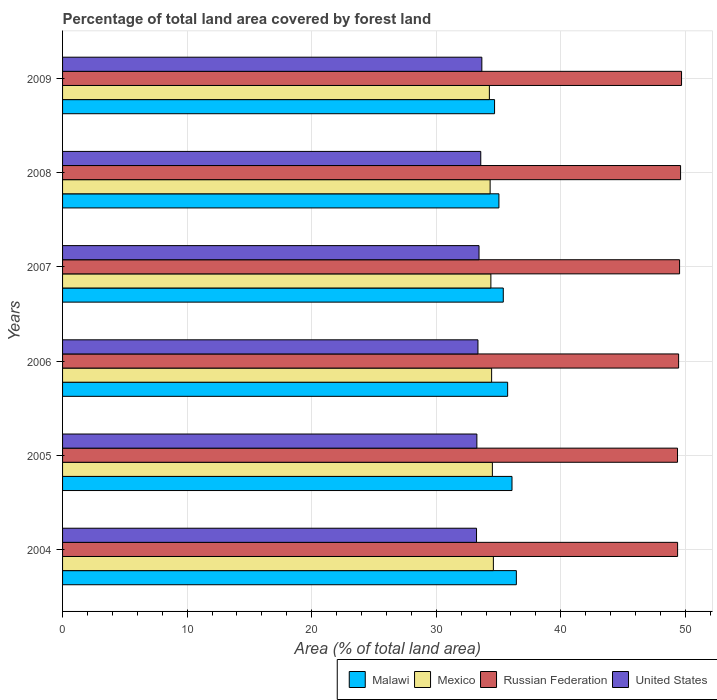How many groups of bars are there?
Your answer should be compact. 6. Are the number of bars per tick equal to the number of legend labels?
Offer a terse response. Yes. Are the number of bars on each tick of the Y-axis equal?
Ensure brevity in your answer.  Yes. How many bars are there on the 3rd tick from the top?
Provide a short and direct response. 4. How many bars are there on the 3rd tick from the bottom?
Your answer should be compact. 4. What is the percentage of forest land in Malawi in 2008?
Provide a short and direct response. 35.03. Across all years, what is the maximum percentage of forest land in Malawi?
Provide a succinct answer. 36.43. Across all years, what is the minimum percentage of forest land in Malawi?
Your answer should be compact. 34.68. In which year was the percentage of forest land in Russian Federation minimum?
Make the answer very short. 2005. What is the total percentage of forest land in United States in the graph?
Your answer should be compact. 200.53. What is the difference between the percentage of forest land in United States in 2005 and that in 2008?
Offer a very short reply. -0.31. What is the difference between the percentage of forest land in United States in 2008 and the percentage of forest land in Mexico in 2007?
Provide a short and direct response. -0.81. What is the average percentage of forest land in United States per year?
Your response must be concise. 33.42. In the year 2009, what is the difference between the percentage of forest land in Russian Federation and percentage of forest land in United States?
Ensure brevity in your answer.  16.03. What is the ratio of the percentage of forest land in Russian Federation in 2004 to that in 2006?
Give a very brief answer. 1. Is the percentage of forest land in Mexico in 2007 less than that in 2009?
Your answer should be compact. No. What is the difference between the highest and the second highest percentage of forest land in Mexico?
Make the answer very short. 0.08. What is the difference between the highest and the lowest percentage of forest land in Mexico?
Your answer should be compact. 0.32. In how many years, is the percentage of forest land in Malawi greater than the average percentage of forest land in Malawi taken over all years?
Ensure brevity in your answer.  3. Is it the case that in every year, the sum of the percentage of forest land in United States and percentage of forest land in Mexico is greater than the sum of percentage of forest land in Russian Federation and percentage of forest land in Malawi?
Provide a short and direct response. Yes. What does the 2nd bar from the top in 2007 represents?
Your answer should be very brief. Russian Federation. What does the 1st bar from the bottom in 2009 represents?
Your answer should be very brief. Malawi. Is it the case that in every year, the sum of the percentage of forest land in United States and percentage of forest land in Mexico is greater than the percentage of forest land in Malawi?
Provide a succinct answer. Yes. How many bars are there?
Offer a terse response. 24. Are all the bars in the graph horizontal?
Give a very brief answer. Yes. How many years are there in the graph?
Give a very brief answer. 6. What is the difference between two consecutive major ticks on the X-axis?
Provide a short and direct response. 10. Are the values on the major ticks of X-axis written in scientific E-notation?
Your answer should be very brief. No. Does the graph contain any zero values?
Give a very brief answer. No. Does the graph contain grids?
Your answer should be very brief. Yes. How are the legend labels stacked?
Make the answer very short. Horizontal. What is the title of the graph?
Offer a very short reply. Percentage of total land area covered by forest land. Does "Canada" appear as one of the legend labels in the graph?
Make the answer very short. No. What is the label or title of the X-axis?
Give a very brief answer. Area (% of total land area). What is the label or title of the Y-axis?
Your response must be concise. Years. What is the Area (% of total land area) in Malawi in 2004?
Provide a short and direct response. 36.43. What is the Area (% of total land area) of Mexico in 2004?
Your answer should be very brief. 34.59. What is the Area (% of total land area) of Russian Federation in 2004?
Offer a terse response. 49.38. What is the Area (% of total land area) in United States in 2004?
Your answer should be compact. 33.24. What is the Area (% of total land area) in Malawi in 2005?
Ensure brevity in your answer.  36.08. What is the Area (% of total land area) in Mexico in 2005?
Your answer should be very brief. 34.51. What is the Area (% of total land area) of Russian Federation in 2005?
Your answer should be very brief. 49.37. What is the Area (% of total land area) of United States in 2005?
Keep it short and to the point. 33.26. What is the Area (% of total land area) of Malawi in 2006?
Keep it short and to the point. 35.73. What is the Area (% of total land area) in Mexico in 2006?
Provide a succinct answer. 34.45. What is the Area (% of total land area) in Russian Federation in 2006?
Ensure brevity in your answer.  49.46. What is the Area (% of total land area) in United States in 2006?
Offer a very short reply. 33.35. What is the Area (% of total land area) in Malawi in 2007?
Your answer should be very brief. 35.38. What is the Area (% of total land area) in Mexico in 2007?
Ensure brevity in your answer.  34.39. What is the Area (% of total land area) in Russian Federation in 2007?
Keep it short and to the point. 49.54. What is the Area (% of total land area) in United States in 2007?
Your answer should be compact. 33.44. What is the Area (% of total land area) of Malawi in 2008?
Provide a short and direct response. 35.03. What is the Area (% of total land area) of Mexico in 2008?
Give a very brief answer. 34.33. What is the Area (% of total land area) of Russian Federation in 2008?
Your answer should be compact. 49.62. What is the Area (% of total land area) in United States in 2008?
Your response must be concise. 33.58. What is the Area (% of total land area) in Malawi in 2009?
Provide a succinct answer. 34.68. What is the Area (% of total land area) of Mexico in 2009?
Offer a very short reply. 34.27. What is the Area (% of total land area) of Russian Federation in 2009?
Offer a very short reply. 49.7. What is the Area (% of total land area) in United States in 2009?
Your answer should be compact. 33.66. Across all years, what is the maximum Area (% of total land area) in Malawi?
Your answer should be compact. 36.43. Across all years, what is the maximum Area (% of total land area) in Mexico?
Give a very brief answer. 34.59. Across all years, what is the maximum Area (% of total land area) in Russian Federation?
Offer a terse response. 49.7. Across all years, what is the maximum Area (% of total land area) of United States?
Provide a succinct answer. 33.66. Across all years, what is the minimum Area (% of total land area) in Malawi?
Make the answer very short. 34.68. Across all years, what is the minimum Area (% of total land area) of Mexico?
Your answer should be compact. 34.27. Across all years, what is the minimum Area (% of total land area) of Russian Federation?
Provide a succinct answer. 49.37. Across all years, what is the minimum Area (% of total land area) in United States?
Give a very brief answer. 33.24. What is the total Area (% of total land area) in Malawi in the graph?
Offer a terse response. 213.35. What is the total Area (% of total land area) in Mexico in the graph?
Ensure brevity in your answer.  206.53. What is the total Area (% of total land area) in Russian Federation in the graph?
Your response must be concise. 297.07. What is the total Area (% of total land area) of United States in the graph?
Give a very brief answer. 200.53. What is the difference between the Area (% of total land area) of Malawi in 2004 and that in 2005?
Your answer should be very brief. 0.35. What is the difference between the Area (% of total land area) of Mexico in 2004 and that in 2005?
Ensure brevity in your answer.  0.08. What is the difference between the Area (% of total land area) of Russian Federation in 2004 and that in 2005?
Give a very brief answer. 0.01. What is the difference between the Area (% of total land area) in United States in 2004 and that in 2005?
Make the answer very short. -0.03. What is the difference between the Area (% of total land area) of Mexico in 2004 and that in 2006?
Keep it short and to the point. 0.14. What is the difference between the Area (% of total land area) of Russian Federation in 2004 and that in 2006?
Your answer should be very brief. -0.08. What is the difference between the Area (% of total land area) in United States in 2004 and that in 2006?
Your response must be concise. -0.11. What is the difference between the Area (% of total land area) in Malawi in 2004 and that in 2007?
Provide a short and direct response. 1.05. What is the difference between the Area (% of total land area) of Mexico in 2004 and that in 2007?
Offer a terse response. 0.2. What is the difference between the Area (% of total land area) in Russian Federation in 2004 and that in 2007?
Ensure brevity in your answer.  -0.16. What is the difference between the Area (% of total land area) in United States in 2004 and that in 2007?
Your answer should be compact. -0.2. What is the difference between the Area (% of total land area) in Malawi in 2004 and that in 2008?
Your answer should be compact. 1.4. What is the difference between the Area (% of total land area) of Mexico in 2004 and that in 2008?
Provide a short and direct response. 0.26. What is the difference between the Area (% of total land area) in Russian Federation in 2004 and that in 2008?
Make the answer very short. -0.24. What is the difference between the Area (% of total land area) in United States in 2004 and that in 2008?
Keep it short and to the point. -0.34. What is the difference between the Area (% of total land area) in Malawi in 2004 and that in 2009?
Provide a short and direct response. 1.75. What is the difference between the Area (% of total land area) in Mexico in 2004 and that in 2009?
Your response must be concise. 0.32. What is the difference between the Area (% of total land area) of Russian Federation in 2004 and that in 2009?
Your response must be concise. -0.32. What is the difference between the Area (% of total land area) in United States in 2004 and that in 2009?
Offer a terse response. -0.43. What is the difference between the Area (% of total land area) in Mexico in 2005 and that in 2006?
Offer a terse response. 0.06. What is the difference between the Area (% of total land area) in Russian Federation in 2005 and that in 2006?
Offer a terse response. -0.09. What is the difference between the Area (% of total land area) of United States in 2005 and that in 2006?
Offer a terse response. -0.09. What is the difference between the Area (% of total land area) in Mexico in 2005 and that in 2007?
Keep it short and to the point. 0.12. What is the difference between the Area (% of total land area) in Russian Federation in 2005 and that in 2007?
Make the answer very short. -0.17. What is the difference between the Area (% of total land area) of United States in 2005 and that in 2007?
Your answer should be very brief. -0.17. What is the difference between the Area (% of total land area) in Malawi in 2005 and that in 2008?
Your answer should be compact. 1.05. What is the difference between the Area (% of total land area) in Mexico in 2005 and that in 2008?
Provide a succinct answer. 0.18. What is the difference between the Area (% of total land area) of Russian Federation in 2005 and that in 2008?
Offer a terse response. -0.25. What is the difference between the Area (% of total land area) of United States in 2005 and that in 2008?
Your response must be concise. -0.31. What is the difference between the Area (% of total land area) in Malawi in 2005 and that in 2009?
Provide a short and direct response. 1.4. What is the difference between the Area (% of total land area) in Mexico in 2005 and that in 2009?
Provide a succinct answer. 0.24. What is the difference between the Area (% of total land area) of Russian Federation in 2005 and that in 2009?
Keep it short and to the point. -0.32. What is the difference between the Area (% of total land area) of United States in 2005 and that in 2009?
Your answer should be compact. -0.4. What is the difference between the Area (% of total land area) of Malawi in 2006 and that in 2007?
Offer a very short reply. 0.35. What is the difference between the Area (% of total land area) in Mexico in 2006 and that in 2007?
Give a very brief answer. 0.06. What is the difference between the Area (% of total land area) of Russian Federation in 2006 and that in 2007?
Provide a short and direct response. -0.08. What is the difference between the Area (% of total land area) of United States in 2006 and that in 2007?
Ensure brevity in your answer.  -0.09. What is the difference between the Area (% of total land area) in Mexico in 2006 and that in 2008?
Provide a succinct answer. 0.12. What is the difference between the Area (% of total land area) in Russian Federation in 2006 and that in 2008?
Your answer should be very brief. -0.16. What is the difference between the Area (% of total land area) in United States in 2006 and that in 2008?
Your answer should be very brief. -0.23. What is the difference between the Area (% of total land area) in Malawi in 2006 and that in 2009?
Make the answer very short. 1.05. What is the difference between the Area (% of total land area) in Mexico in 2006 and that in 2009?
Ensure brevity in your answer.  0.18. What is the difference between the Area (% of total land area) of Russian Federation in 2006 and that in 2009?
Make the answer very short. -0.24. What is the difference between the Area (% of total land area) of United States in 2006 and that in 2009?
Your response must be concise. -0.31. What is the difference between the Area (% of total land area) of Malawi in 2007 and that in 2008?
Provide a succinct answer. 0.35. What is the difference between the Area (% of total land area) of Mexico in 2007 and that in 2008?
Keep it short and to the point. 0.06. What is the difference between the Area (% of total land area) in Russian Federation in 2007 and that in 2008?
Offer a terse response. -0.08. What is the difference between the Area (% of total land area) in United States in 2007 and that in 2008?
Offer a terse response. -0.14. What is the difference between the Area (% of total land area) of Mexico in 2007 and that in 2009?
Your answer should be very brief. 0.12. What is the difference between the Area (% of total land area) of Russian Federation in 2007 and that in 2009?
Your response must be concise. -0.16. What is the difference between the Area (% of total land area) in United States in 2007 and that in 2009?
Your response must be concise. -0.23. What is the difference between the Area (% of total land area) of Malawi in 2008 and that in 2009?
Your answer should be compact. 0.35. What is the difference between the Area (% of total land area) in Mexico in 2008 and that in 2009?
Your response must be concise. 0.06. What is the difference between the Area (% of total land area) of Russian Federation in 2008 and that in 2009?
Your answer should be very brief. -0.08. What is the difference between the Area (% of total land area) in United States in 2008 and that in 2009?
Offer a terse response. -0.09. What is the difference between the Area (% of total land area) of Malawi in 2004 and the Area (% of total land area) of Mexico in 2005?
Give a very brief answer. 1.93. What is the difference between the Area (% of total land area) of Malawi in 2004 and the Area (% of total land area) of Russian Federation in 2005?
Provide a short and direct response. -12.94. What is the difference between the Area (% of total land area) in Malawi in 2004 and the Area (% of total land area) in United States in 2005?
Ensure brevity in your answer.  3.17. What is the difference between the Area (% of total land area) of Mexico in 2004 and the Area (% of total land area) of Russian Federation in 2005?
Keep it short and to the point. -14.78. What is the difference between the Area (% of total land area) of Mexico in 2004 and the Area (% of total land area) of United States in 2005?
Your answer should be very brief. 1.32. What is the difference between the Area (% of total land area) in Russian Federation in 2004 and the Area (% of total land area) in United States in 2005?
Your answer should be very brief. 16.12. What is the difference between the Area (% of total land area) in Malawi in 2004 and the Area (% of total land area) in Mexico in 2006?
Provide a succinct answer. 1.99. What is the difference between the Area (% of total land area) in Malawi in 2004 and the Area (% of total land area) in Russian Federation in 2006?
Keep it short and to the point. -13.03. What is the difference between the Area (% of total land area) in Malawi in 2004 and the Area (% of total land area) in United States in 2006?
Keep it short and to the point. 3.08. What is the difference between the Area (% of total land area) of Mexico in 2004 and the Area (% of total land area) of Russian Federation in 2006?
Ensure brevity in your answer.  -14.87. What is the difference between the Area (% of total land area) in Mexico in 2004 and the Area (% of total land area) in United States in 2006?
Provide a short and direct response. 1.24. What is the difference between the Area (% of total land area) of Russian Federation in 2004 and the Area (% of total land area) of United States in 2006?
Offer a terse response. 16.03. What is the difference between the Area (% of total land area) in Malawi in 2004 and the Area (% of total land area) in Mexico in 2007?
Give a very brief answer. 2.05. What is the difference between the Area (% of total land area) of Malawi in 2004 and the Area (% of total land area) of Russian Federation in 2007?
Your answer should be very brief. -13.1. What is the difference between the Area (% of total land area) in Malawi in 2004 and the Area (% of total land area) in United States in 2007?
Provide a short and direct response. 3. What is the difference between the Area (% of total land area) in Mexico in 2004 and the Area (% of total land area) in Russian Federation in 2007?
Provide a succinct answer. -14.95. What is the difference between the Area (% of total land area) of Mexico in 2004 and the Area (% of total land area) of United States in 2007?
Offer a terse response. 1.15. What is the difference between the Area (% of total land area) in Russian Federation in 2004 and the Area (% of total land area) in United States in 2007?
Provide a short and direct response. 15.94. What is the difference between the Area (% of total land area) in Malawi in 2004 and the Area (% of total land area) in Mexico in 2008?
Make the answer very short. 2.11. What is the difference between the Area (% of total land area) in Malawi in 2004 and the Area (% of total land area) in Russian Federation in 2008?
Provide a succinct answer. -13.18. What is the difference between the Area (% of total land area) in Malawi in 2004 and the Area (% of total land area) in United States in 2008?
Provide a short and direct response. 2.86. What is the difference between the Area (% of total land area) in Mexico in 2004 and the Area (% of total land area) in Russian Federation in 2008?
Your response must be concise. -15.03. What is the difference between the Area (% of total land area) in Mexico in 2004 and the Area (% of total land area) in United States in 2008?
Your answer should be very brief. 1.01. What is the difference between the Area (% of total land area) in Russian Federation in 2004 and the Area (% of total land area) in United States in 2008?
Ensure brevity in your answer.  15.8. What is the difference between the Area (% of total land area) of Malawi in 2004 and the Area (% of total land area) of Mexico in 2009?
Your response must be concise. 2.17. What is the difference between the Area (% of total land area) in Malawi in 2004 and the Area (% of total land area) in Russian Federation in 2009?
Make the answer very short. -13.26. What is the difference between the Area (% of total land area) of Malawi in 2004 and the Area (% of total land area) of United States in 2009?
Your answer should be compact. 2.77. What is the difference between the Area (% of total land area) of Mexico in 2004 and the Area (% of total land area) of Russian Federation in 2009?
Your answer should be very brief. -15.11. What is the difference between the Area (% of total land area) of Mexico in 2004 and the Area (% of total land area) of United States in 2009?
Your response must be concise. 0.93. What is the difference between the Area (% of total land area) of Russian Federation in 2004 and the Area (% of total land area) of United States in 2009?
Your response must be concise. 15.72. What is the difference between the Area (% of total land area) in Malawi in 2005 and the Area (% of total land area) in Mexico in 2006?
Your answer should be compact. 1.64. What is the difference between the Area (% of total land area) in Malawi in 2005 and the Area (% of total land area) in Russian Federation in 2006?
Offer a terse response. -13.38. What is the difference between the Area (% of total land area) in Malawi in 2005 and the Area (% of total land area) in United States in 2006?
Make the answer very short. 2.73. What is the difference between the Area (% of total land area) of Mexico in 2005 and the Area (% of total land area) of Russian Federation in 2006?
Offer a terse response. -14.95. What is the difference between the Area (% of total land area) in Mexico in 2005 and the Area (% of total land area) in United States in 2006?
Your response must be concise. 1.16. What is the difference between the Area (% of total land area) in Russian Federation in 2005 and the Area (% of total land area) in United States in 2006?
Give a very brief answer. 16.02. What is the difference between the Area (% of total land area) in Malawi in 2005 and the Area (% of total land area) in Mexico in 2007?
Your answer should be compact. 1.7. What is the difference between the Area (% of total land area) of Malawi in 2005 and the Area (% of total land area) of Russian Federation in 2007?
Provide a short and direct response. -13.45. What is the difference between the Area (% of total land area) of Malawi in 2005 and the Area (% of total land area) of United States in 2007?
Give a very brief answer. 2.65. What is the difference between the Area (% of total land area) in Mexico in 2005 and the Area (% of total land area) in Russian Federation in 2007?
Provide a short and direct response. -15.03. What is the difference between the Area (% of total land area) of Mexico in 2005 and the Area (% of total land area) of United States in 2007?
Ensure brevity in your answer.  1.07. What is the difference between the Area (% of total land area) in Russian Federation in 2005 and the Area (% of total land area) in United States in 2007?
Your answer should be very brief. 15.94. What is the difference between the Area (% of total land area) of Malawi in 2005 and the Area (% of total land area) of Mexico in 2008?
Ensure brevity in your answer.  1.76. What is the difference between the Area (% of total land area) in Malawi in 2005 and the Area (% of total land area) in Russian Federation in 2008?
Ensure brevity in your answer.  -13.53. What is the difference between the Area (% of total land area) of Malawi in 2005 and the Area (% of total land area) of United States in 2008?
Offer a terse response. 2.51. What is the difference between the Area (% of total land area) of Mexico in 2005 and the Area (% of total land area) of Russian Federation in 2008?
Ensure brevity in your answer.  -15.11. What is the difference between the Area (% of total land area) in Mexico in 2005 and the Area (% of total land area) in United States in 2008?
Offer a terse response. 0.93. What is the difference between the Area (% of total land area) of Russian Federation in 2005 and the Area (% of total land area) of United States in 2008?
Keep it short and to the point. 15.8. What is the difference between the Area (% of total land area) of Malawi in 2005 and the Area (% of total land area) of Mexico in 2009?
Your answer should be very brief. 1.82. What is the difference between the Area (% of total land area) in Malawi in 2005 and the Area (% of total land area) in Russian Federation in 2009?
Make the answer very short. -13.61. What is the difference between the Area (% of total land area) in Malawi in 2005 and the Area (% of total land area) in United States in 2009?
Give a very brief answer. 2.42. What is the difference between the Area (% of total land area) in Mexico in 2005 and the Area (% of total land area) in Russian Federation in 2009?
Ensure brevity in your answer.  -15.19. What is the difference between the Area (% of total land area) of Mexico in 2005 and the Area (% of total land area) of United States in 2009?
Offer a terse response. 0.85. What is the difference between the Area (% of total land area) of Russian Federation in 2005 and the Area (% of total land area) of United States in 2009?
Provide a succinct answer. 15.71. What is the difference between the Area (% of total land area) of Malawi in 2006 and the Area (% of total land area) of Mexico in 2007?
Your answer should be very brief. 1.35. What is the difference between the Area (% of total land area) of Malawi in 2006 and the Area (% of total land area) of Russian Federation in 2007?
Ensure brevity in your answer.  -13.8. What is the difference between the Area (% of total land area) in Malawi in 2006 and the Area (% of total land area) in United States in 2007?
Make the answer very short. 2.3. What is the difference between the Area (% of total land area) in Mexico in 2006 and the Area (% of total land area) in Russian Federation in 2007?
Give a very brief answer. -15.09. What is the difference between the Area (% of total land area) in Russian Federation in 2006 and the Area (% of total land area) in United States in 2007?
Offer a very short reply. 16.02. What is the difference between the Area (% of total land area) of Malawi in 2006 and the Area (% of total land area) of Mexico in 2008?
Your response must be concise. 1.41. What is the difference between the Area (% of total land area) in Malawi in 2006 and the Area (% of total land area) in Russian Federation in 2008?
Your answer should be very brief. -13.88. What is the difference between the Area (% of total land area) of Malawi in 2006 and the Area (% of total land area) of United States in 2008?
Give a very brief answer. 2.16. What is the difference between the Area (% of total land area) in Mexico in 2006 and the Area (% of total land area) in Russian Federation in 2008?
Provide a short and direct response. -15.17. What is the difference between the Area (% of total land area) of Mexico in 2006 and the Area (% of total land area) of United States in 2008?
Keep it short and to the point. 0.87. What is the difference between the Area (% of total land area) in Russian Federation in 2006 and the Area (% of total land area) in United States in 2008?
Your answer should be very brief. 15.88. What is the difference between the Area (% of total land area) of Malawi in 2006 and the Area (% of total land area) of Mexico in 2009?
Your response must be concise. 1.47. What is the difference between the Area (% of total land area) of Malawi in 2006 and the Area (% of total land area) of Russian Federation in 2009?
Offer a terse response. -13.96. What is the difference between the Area (% of total land area) of Malawi in 2006 and the Area (% of total land area) of United States in 2009?
Provide a succinct answer. 2.07. What is the difference between the Area (% of total land area) in Mexico in 2006 and the Area (% of total land area) in Russian Federation in 2009?
Your answer should be very brief. -15.25. What is the difference between the Area (% of total land area) in Mexico in 2006 and the Area (% of total land area) in United States in 2009?
Provide a succinct answer. 0.79. What is the difference between the Area (% of total land area) in Russian Federation in 2006 and the Area (% of total land area) in United States in 2009?
Keep it short and to the point. 15.8. What is the difference between the Area (% of total land area) in Malawi in 2007 and the Area (% of total land area) in Mexico in 2008?
Keep it short and to the point. 1.06. What is the difference between the Area (% of total land area) of Malawi in 2007 and the Area (% of total land area) of Russian Federation in 2008?
Provide a short and direct response. -14.23. What is the difference between the Area (% of total land area) of Malawi in 2007 and the Area (% of total land area) of United States in 2008?
Offer a very short reply. 1.81. What is the difference between the Area (% of total land area) in Mexico in 2007 and the Area (% of total land area) in Russian Federation in 2008?
Your answer should be very brief. -15.23. What is the difference between the Area (% of total land area) of Mexico in 2007 and the Area (% of total land area) of United States in 2008?
Make the answer very short. 0.81. What is the difference between the Area (% of total land area) of Russian Federation in 2007 and the Area (% of total land area) of United States in 2008?
Give a very brief answer. 15.96. What is the difference between the Area (% of total land area) in Malawi in 2007 and the Area (% of total land area) in Mexico in 2009?
Your answer should be very brief. 1.12. What is the difference between the Area (% of total land area) of Malawi in 2007 and the Area (% of total land area) of Russian Federation in 2009?
Ensure brevity in your answer.  -14.31. What is the difference between the Area (% of total land area) of Malawi in 2007 and the Area (% of total land area) of United States in 2009?
Your response must be concise. 1.72. What is the difference between the Area (% of total land area) in Mexico in 2007 and the Area (% of total land area) in Russian Federation in 2009?
Offer a very short reply. -15.31. What is the difference between the Area (% of total land area) in Mexico in 2007 and the Area (% of total land area) in United States in 2009?
Offer a terse response. 0.73. What is the difference between the Area (% of total land area) in Russian Federation in 2007 and the Area (% of total land area) in United States in 2009?
Your answer should be compact. 15.88. What is the difference between the Area (% of total land area) of Malawi in 2008 and the Area (% of total land area) of Mexico in 2009?
Your response must be concise. 0.77. What is the difference between the Area (% of total land area) of Malawi in 2008 and the Area (% of total land area) of Russian Federation in 2009?
Keep it short and to the point. -14.66. What is the difference between the Area (% of total land area) of Malawi in 2008 and the Area (% of total land area) of United States in 2009?
Your answer should be very brief. 1.37. What is the difference between the Area (% of total land area) in Mexico in 2008 and the Area (% of total land area) in Russian Federation in 2009?
Give a very brief answer. -15.37. What is the difference between the Area (% of total land area) in Mexico in 2008 and the Area (% of total land area) in United States in 2009?
Your answer should be compact. 0.67. What is the difference between the Area (% of total land area) of Russian Federation in 2008 and the Area (% of total land area) of United States in 2009?
Provide a succinct answer. 15.96. What is the average Area (% of total land area) in Malawi per year?
Your answer should be very brief. 35.56. What is the average Area (% of total land area) of Mexico per year?
Your response must be concise. 34.42. What is the average Area (% of total land area) of Russian Federation per year?
Your answer should be very brief. 49.51. What is the average Area (% of total land area) of United States per year?
Your response must be concise. 33.42. In the year 2004, what is the difference between the Area (% of total land area) of Malawi and Area (% of total land area) of Mexico?
Make the answer very short. 1.85. In the year 2004, what is the difference between the Area (% of total land area) of Malawi and Area (% of total land area) of Russian Federation?
Offer a very short reply. -12.94. In the year 2004, what is the difference between the Area (% of total land area) in Malawi and Area (% of total land area) in United States?
Provide a short and direct response. 3.2. In the year 2004, what is the difference between the Area (% of total land area) of Mexico and Area (% of total land area) of Russian Federation?
Make the answer very short. -14.79. In the year 2004, what is the difference between the Area (% of total land area) in Mexico and Area (% of total land area) in United States?
Offer a terse response. 1.35. In the year 2004, what is the difference between the Area (% of total land area) in Russian Federation and Area (% of total land area) in United States?
Your answer should be very brief. 16.14. In the year 2005, what is the difference between the Area (% of total land area) of Malawi and Area (% of total land area) of Mexico?
Give a very brief answer. 1.58. In the year 2005, what is the difference between the Area (% of total land area) in Malawi and Area (% of total land area) in Russian Federation?
Keep it short and to the point. -13.29. In the year 2005, what is the difference between the Area (% of total land area) in Malawi and Area (% of total land area) in United States?
Offer a terse response. 2.82. In the year 2005, what is the difference between the Area (% of total land area) of Mexico and Area (% of total land area) of Russian Federation?
Make the answer very short. -14.86. In the year 2005, what is the difference between the Area (% of total land area) of Mexico and Area (% of total land area) of United States?
Your answer should be compact. 1.25. In the year 2005, what is the difference between the Area (% of total land area) of Russian Federation and Area (% of total land area) of United States?
Ensure brevity in your answer.  16.11. In the year 2006, what is the difference between the Area (% of total land area) in Malawi and Area (% of total land area) in Mexico?
Your response must be concise. 1.29. In the year 2006, what is the difference between the Area (% of total land area) of Malawi and Area (% of total land area) of Russian Federation?
Your response must be concise. -13.73. In the year 2006, what is the difference between the Area (% of total land area) of Malawi and Area (% of total land area) of United States?
Offer a very short reply. 2.38. In the year 2006, what is the difference between the Area (% of total land area) in Mexico and Area (% of total land area) in Russian Federation?
Offer a terse response. -15.01. In the year 2006, what is the difference between the Area (% of total land area) of Mexico and Area (% of total land area) of United States?
Your answer should be very brief. 1.1. In the year 2006, what is the difference between the Area (% of total land area) of Russian Federation and Area (% of total land area) of United States?
Ensure brevity in your answer.  16.11. In the year 2007, what is the difference between the Area (% of total land area) of Malawi and Area (% of total land area) of Russian Federation?
Your answer should be very brief. -14.15. In the year 2007, what is the difference between the Area (% of total land area) in Malawi and Area (% of total land area) in United States?
Your response must be concise. 1.95. In the year 2007, what is the difference between the Area (% of total land area) of Mexico and Area (% of total land area) of Russian Federation?
Give a very brief answer. -15.15. In the year 2007, what is the difference between the Area (% of total land area) of Mexico and Area (% of total land area) of United States?
Provide a short and direct response. 0.95. In the year 2007, what is the difference between the Area (% of total land area) of Russian Federation and Area (% of total land area) of United States?
Offer a terse response. 16.1. In the year 2008, what is the difference between the Area (% of total land area) in Malawi and Area (% of total land area) in Mexico?
Offer a terse response. 0.71. In the year 2008, what is the difference between the Area (% of total land area) of Malawi and Area (% of total land area) of Russian Federation?
Provide a short and direct response. -14.58. In the year 2008, what is the difference between the Area (% of total land area) of Malawi and Area (% of total land area) of United States?
Your answer should be very brief. 1.46. In the year 2008, what is the difference between the Area (% of total land area) of Mexico and Area (% of total land area) of Russian Federation?
Provide a succinct answer. -15.29. In the year 2008, what is the difference between the Area (% of total land area) in Mexico and Area (% of total land area) in United States?
Keep it short and to the point. 0.75. In the year 2008, what is the difference between the Area (% of total land area) in Russian Federation and Area (% of total land area) in United States?
Keep it short and to the point. 16.04. In the year 2009, what is the difference between the Area (% of total land area) of Malawi and Area (% of total land area) of Mexico?
Offer a terse response. 0.42. In the year 2009, what is the difference between the Area (% of total land area) of Malawi and Area (% of total land area) of Russian Federation?
Give a very brief answer. -15.01. In the year 2009, what is the difference between the Area (% of total land area) in Malawi and Area (% of total land area) in United States?
Give a very brief answer. 1.02. In the year 2009, what is the difference between the Area (% of total land area) in Mexico and Area (% of total land area) in Russian Federation?
Offer a very short reply. -15.43. In the year 2009, what is the difference between the Area (% of total land area) in Mexico and Area (% of total land area) in United States?
Provide a succinct answer. 0.61. In the year 2009, what is the difference between the Area (% of total land area) of Russian Federation and Area (% of total land area) of United States?
Offer a very short reply. 16.03. What is the ratio of the Area (% of total land area) in Malawi in 2004 to that in 2005?
Provide a short and direct response. 1.01. What is the ratio of the Area (% of total land area) of Malawi in 2004 to that in 2006?
Your answer should be very brief. 1.02. What is the ratio of the Area (% of total land area) of Mexico in 2004 to that in 2006?
Ensure brevity in your answer.  1. What is the ratio of the Area (% of total land area) in Russian Federation in 2004 to that in 2006?
Provide a succinct answer. 1. What is the ratio of the Area (% of total land area) in Malawi in 2004 to that in 2007?
Your answer should be very brief. 1.03. What is the ratio of the Area (% of total land area) of Mexico in 2004 to that in 2007?
Provide a succinct answer. 1.01. What is the ratio of the Area (% of total land area) in United States in 2004 to that in 2007?
Offer a very short reply. 0.99. What is the ratio of the Area (% of total land area) in Mexico in 2004 to that in 2008?
Your response must be concise. 1.01. What is the ratio of the Area (% of total land area) in Russian Federation in 2004 to that in 2008?
Ensure brevity in your answer.  1. What is the ratio of the Area (% of total land area) in Malawi in 2004 to that in 2009?
Give a very brief answer. 1.05. What is the ratio of the Area (% of total land area) in Mexico in 2004 to that in 2009?
Provide a succinct answer. 1.01. What is the ratio of the Area (% of total land area) of Russian Federation in 2004 to that in 2009?
Provide a short and direct response. 0.99. What is the ratio of the Area (% of total land area) of United States in 2004 to that in 2009?
Make the answer very short. 0.99. What is the ratio of the Area (% of total land area) of Malawi in 2005 to that in 2006?
Keep it short and to the point. 1.01. What is the ratio of the Area (% of total land area) in Mexico in 2005 to that in 2006?
Provide a short and direct response. 1. What is the ratio of the Area (% of total land area) in United States in 2005 to that in 2006?
Your answer should be very brief. 1. What is the ratio of the Area (% of total land area) of Malawi in 2005 to that in 2007?
Provide a short and direct response. 1.02. What is the ratio of the Area (% of total land area) of Mexico in 2005 to that in 2007?
Ensure brevity in your answer.  1. What is the ratio of the Area (% of total land area) in United States in 2005 to that in 2007?
Make the answer very short. 0.99. What is the ratio of the Area (% of total land area) in Mexico in 2005 to that in 2008?
Provide a succinct answer. 1.01. What is the ratio of the Area (% of total land area) of Russian Federation in 2005 to that in 2008?
Provide a short and direct response. 0.99. What is the ratio of the Area (% of total land area) of United States in 2005 to that in 2008?
Make the answer very short. 0.99. What is the ratio of the Area (% of total land area) of Malawi in 2005 to that in 2009?
Offer a very short reply. 1.04. What is the ratio of the Area (% of total land area) of Mexico in 2005 to that in 2009?
Provide a succinct answer. 1.01. What is the ratio of the Area (% of total land area) in Russian Federation in 2005 to that in 2009?
Provide a succinct answer. 0.99. What is the ratio of the Area (% of total land area) in United States in 2005 to that in 2009?
Your answer should be very brief. 0.99. What is the ratio of the Area (% of total land area) of Malawi in 2006 to that in 2007?
Give a very brief answer. 1.01. What is the ratio of the Area (% of total land area) of Russian Federation in 2006 to that in 2007?
Your answer should be compact. 1. What is the ratio of the Area (% of total land area) in Malawi in 2006 to that in 2008?
Your response must be concise. 1.02. What is the ratio of the Area (% of total land area) in Russian Federation in 2006 to that in 2008?
Your response must be concise. 1. What is the ratio of the Area (% of total land area) of Malawi in 2006 to that in 2009?
Your answer should be compact. 1.03. What is the ratio of the Area (% of total land area) in United States in 2006 to that in 2009?
Your answer should be very brief. 0.99. What is the ratio of the Area (% of total land area) of Malawi in 2007 to that in 2009?
Provide a succinct answer. 1.02. What is the ratio of the Area (% of total land area) of Mexico in 2007 to that in 2009?
Your response must be concise. 1. What is the ratio of the Area (% of total land area) of Mexico in 2008 to that in 2009?
Offer a terse response. 1. What is the difference between the highest and the second highest Area (% of total land area) of Malawi?
Provide a succinct answer. 0.35. What is the difference between the highest and the second highest Area (% of total land area) of Mexico?
Make the answer very short. 0.08. What is the difference between the highest and the second highest Area (% of total land area) in Russian Federation?
Offer a terse response. 0.08. What is the difference between the highest and the second highest Area (% of total land area) of United States?
Give a very brief answer. 0.09. What is the difference between the highest and the lowest Area (% of total land area) in Malawi?
Your answer should be compact. 1.75. What is the difference between the highest and the lowest Area (% of total land area) of Mexico?
Offer a very short reply. 0.32. What is the difference between the highest and the lowest Area (% of total land area) of Russian Federation?
Give a very brief answer. 0.32. What is the difference between the highest and the lowest Area (% of total land area) of United States?
Your answer should be very brief. 0.43. 